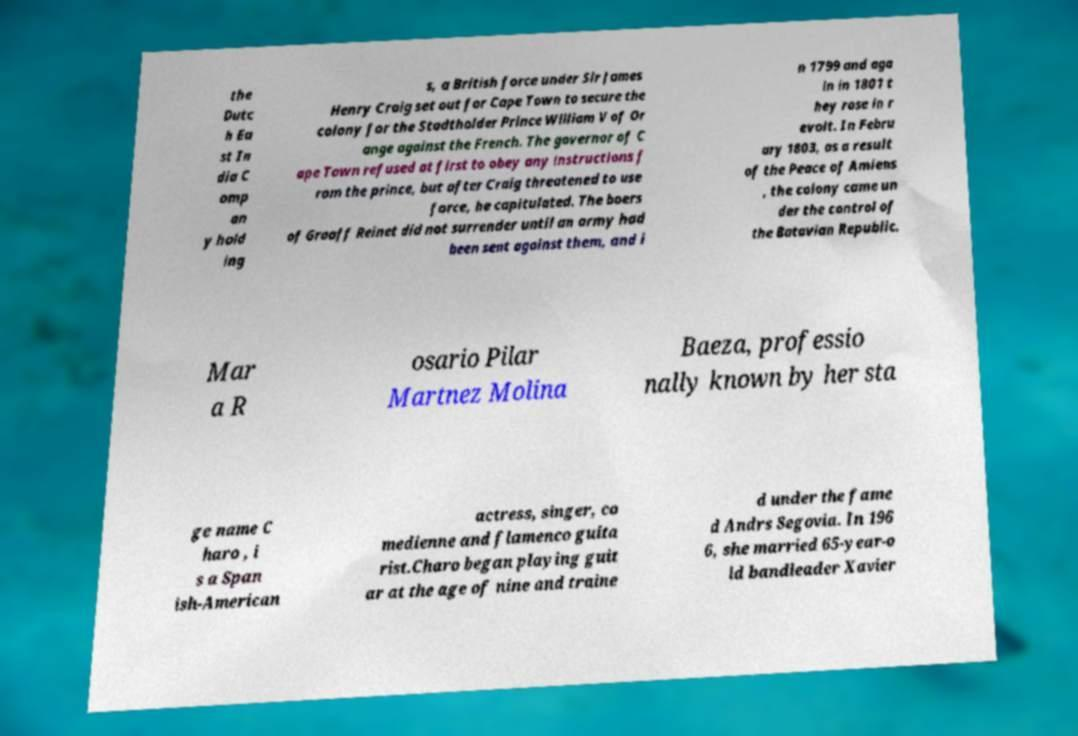Can you accurately transcribe the text from the provided image for me? the Dutc h Ea st In dia C omp an y hold ing s, a British force under Sir James Henry Craig set out for Cape Town to secure the colony for the Stadtholder Prince William V of Or ange against the French. The governor of C ape Town refused at first to obey any instructions f rom the prince, but after Craig threatened to use force, he capitulated. The boers of Graaff Reinet did not surrender until an army had been sent against them, and i n 1799 and aga in in 1801 t hey rose in r evolt. In Febru ary 1803, as a result of the Peace of Amiens , the colony came un der the control of the Batavian Republic. Mar a R osario Pilar Martnez Molina Baeza, professio nally known by her sta ge name C haro , i s a Span ish-American actress, singer, co medienne and flamenco guita rist.Charo began playing guit ar at the age of nine and traine d under the fame d Andrs Segovia. In 196 6, she married 65-year-o ld bandleader Xavier 